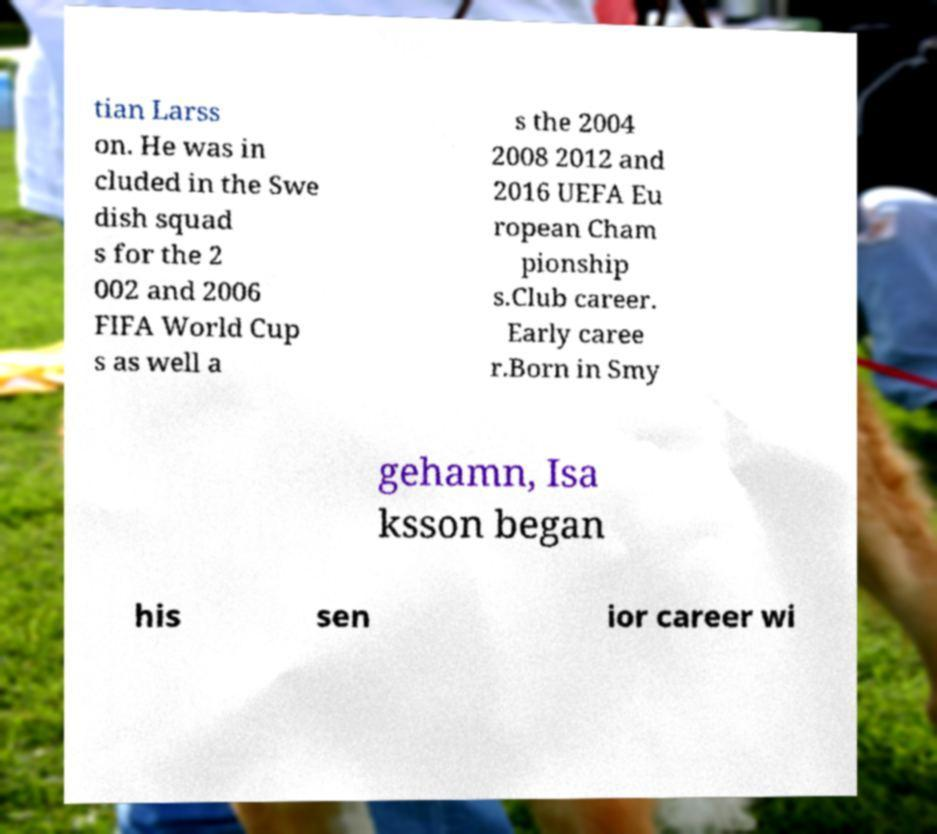I need the written content from this picture converted into text. Can you do that? tian Larss on. He was in cluded in the Swe dish squad s for the 2 002 and 2006 FIFA World Cup s as well a s the 2004 2008 2012 and 2016 UEFA Eu ropean Cham pionship s.Club career. Early caree r.Born in Smy gehamn, Isa ksson began his sen ior career wi 